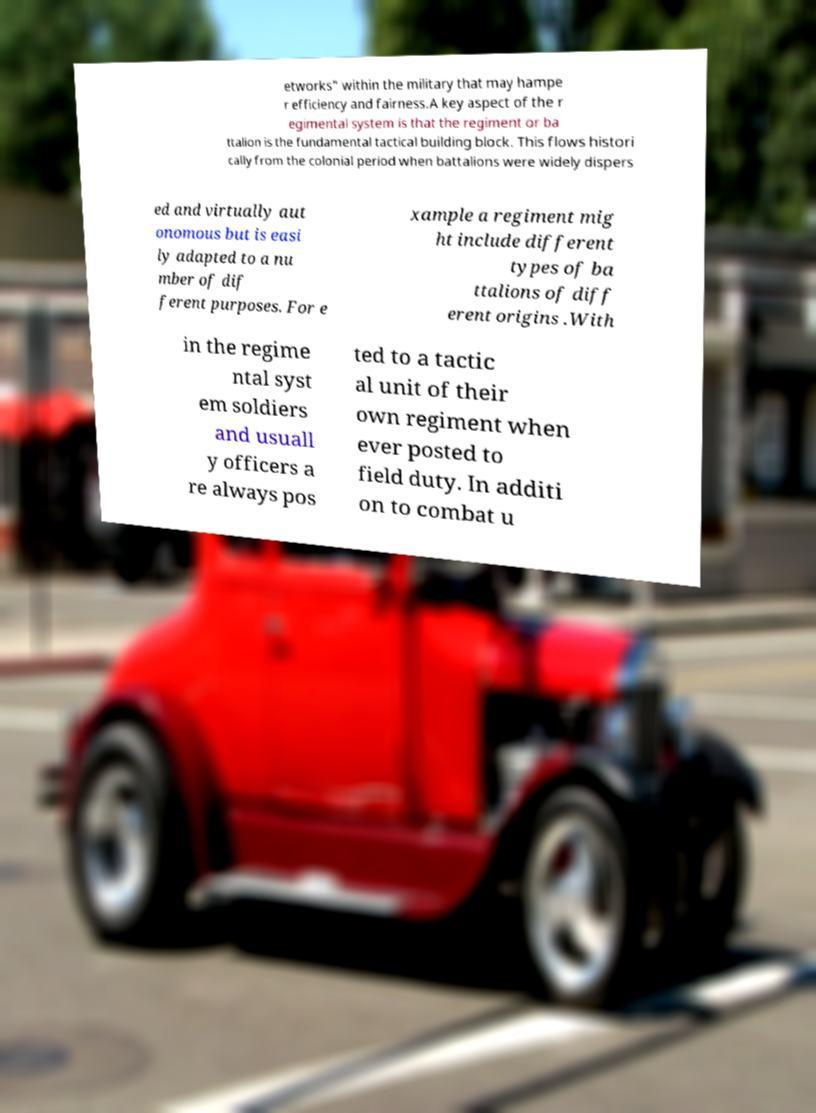Could you assist in decoding the text presented in this image and type it out clearly? etworks" within the military that may hampe r efficiency and fairness.A key aspect of the r egimental system is that the regiment or ba ttalion is the fundamental tactical building block. This flows histori cally from the colonial period when battalions were widely dispers ed and virtually aut onomous but is easi ly adapted to a nu mber of dif ferent purposes. For e xample a regiment mig ht include different types of ba ttalions of diff erent origins .With in the regime ntal syst em soldiers and usuall y officers a re always pos ted to a tactic al unit of their own regiment when ever posted to field duty. In additi on to combat u 